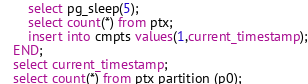Convert code to text. <code><loc_0><loc_0><loc_500><loc_500><_SQL_>	select pg_sleep(5);
	select count(*) from ptx;
	insert into cmpts values(1,current_timestamp);
END;
select current_timestamp;
select count(*) from ptx partition (p0);
</code> 